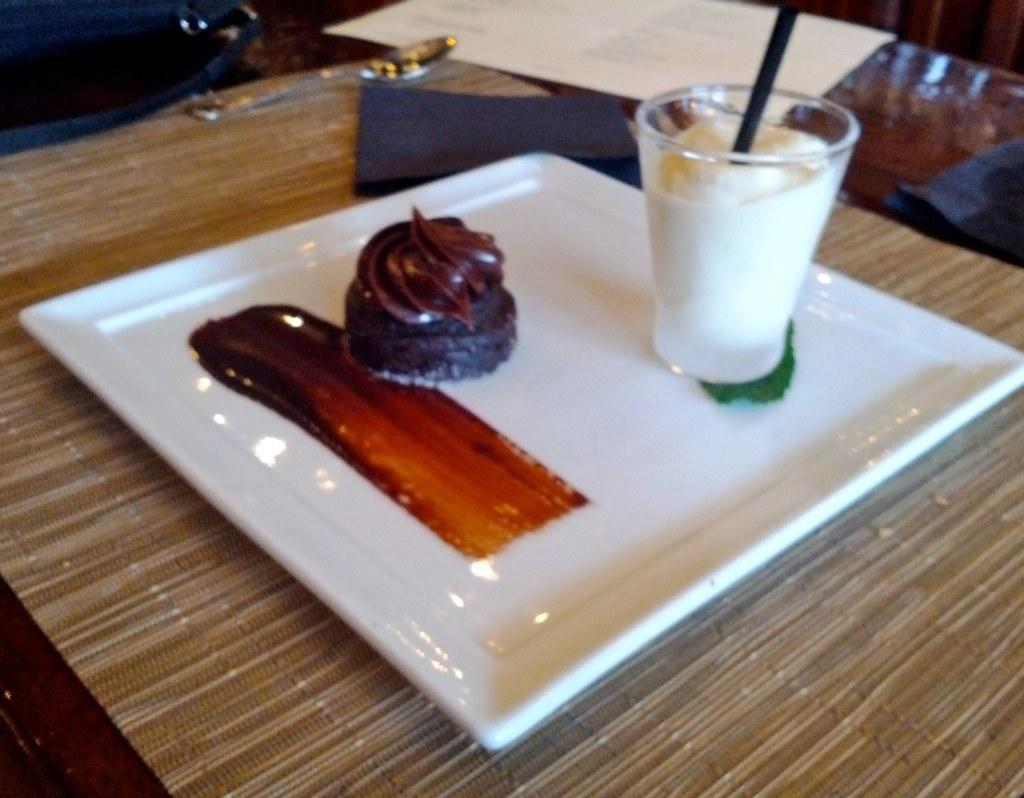Please provide a concise description of this image. In this picture I can observe some food places in the white color plate. The plate is placed on the table. On the right side I can observe a glass. The food is in brown color. 